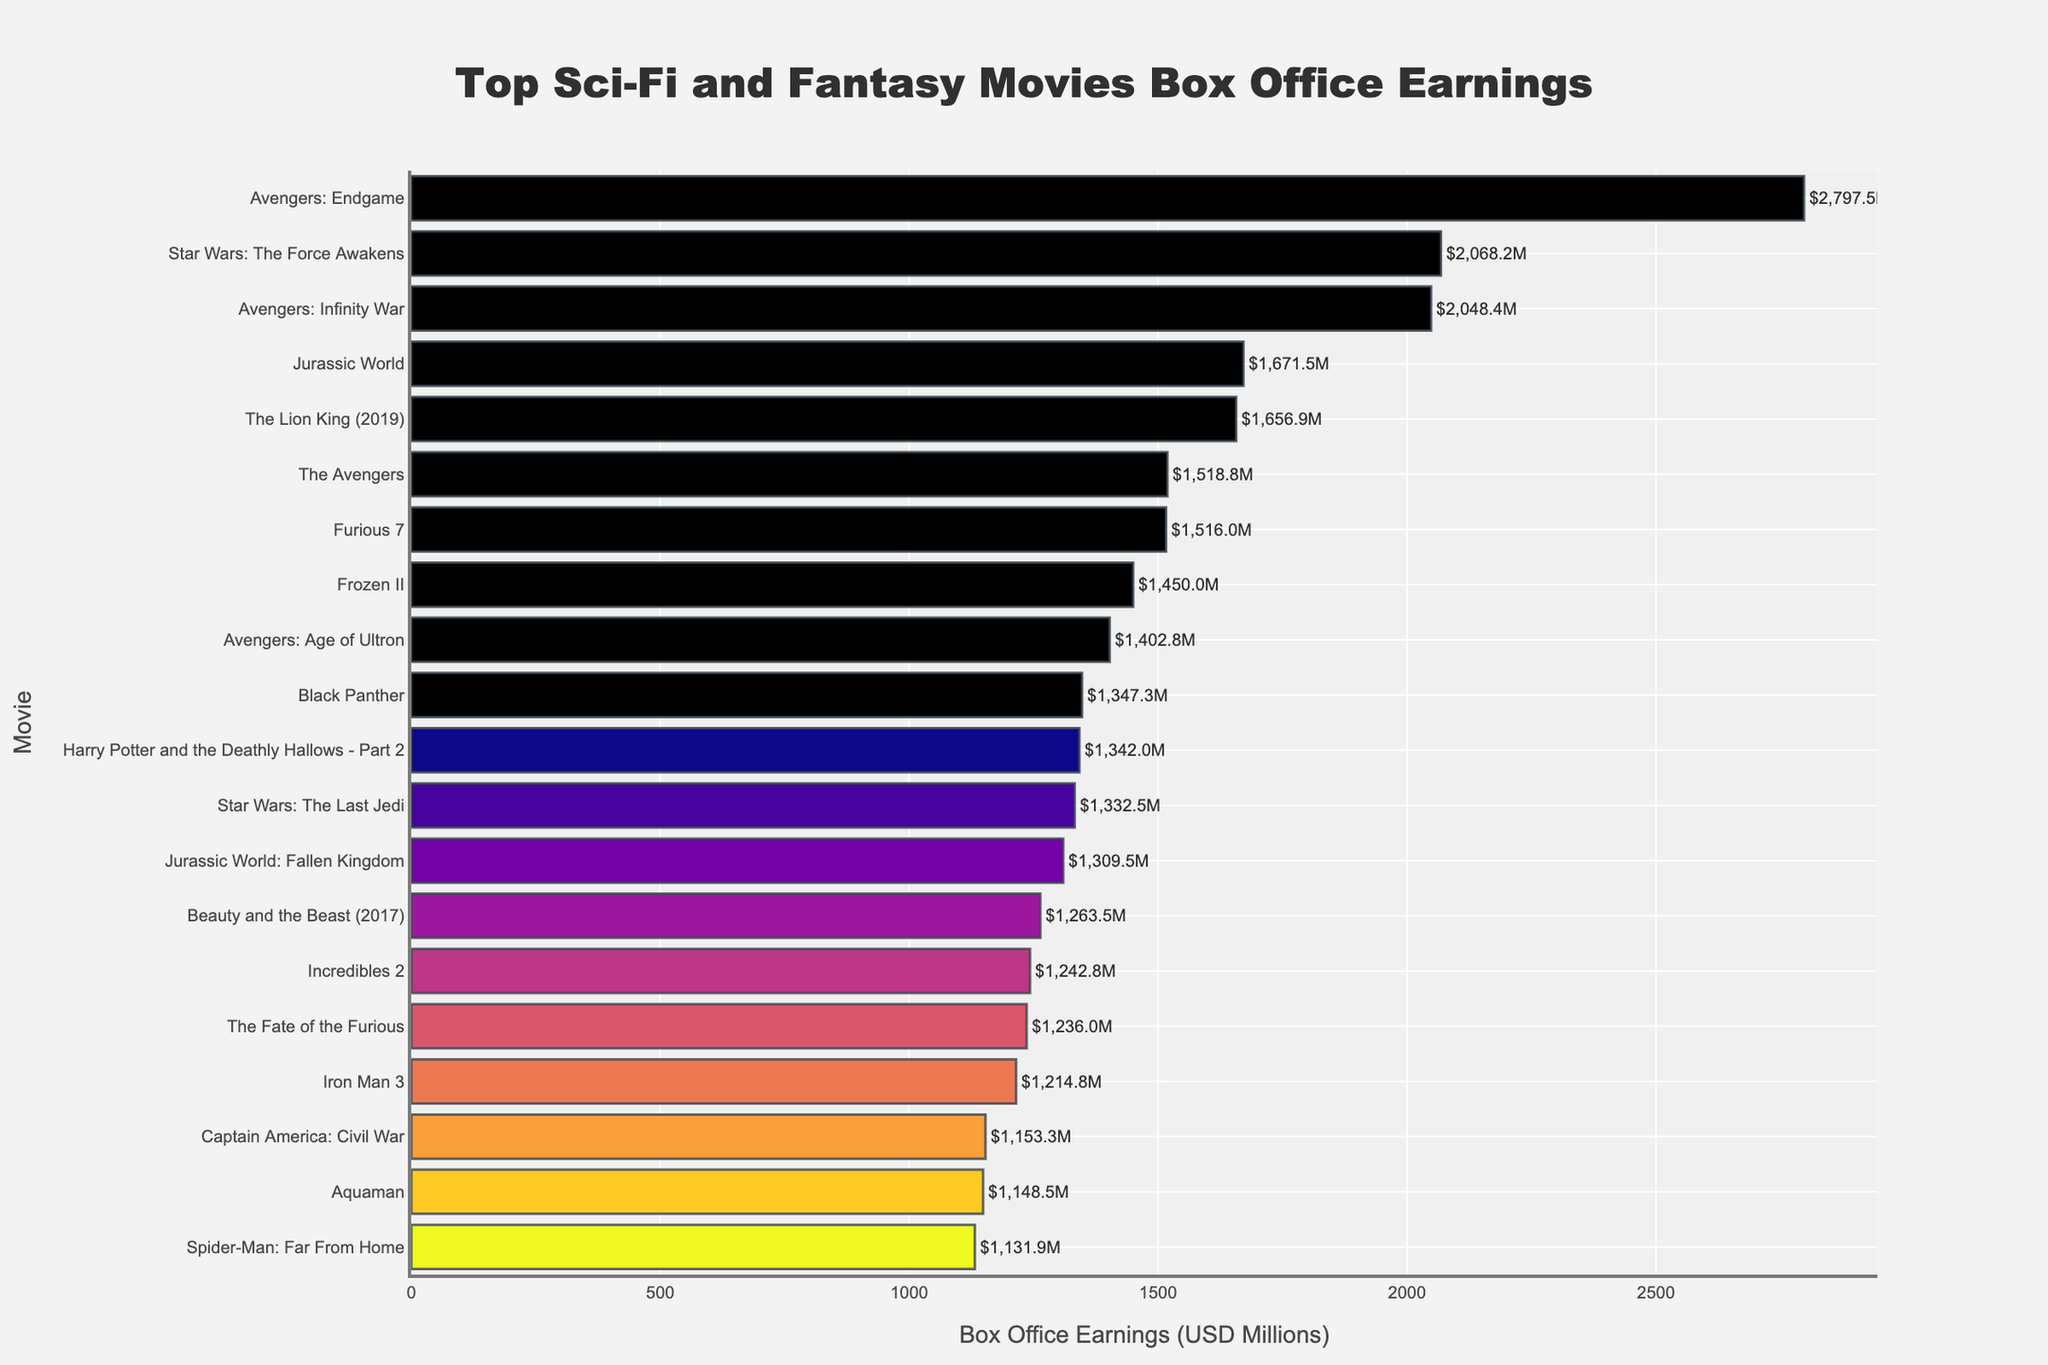Which movie has the highest box office earnings? The bar for "Avengers: Endgame" is the longest, indicating it has the highest earnings among the movies listed.
Answer: Avengers: Endgame Which two movies have box office earnings closest to each other? "Captain America: Civil War" and "Aquaman" have very similar bar lengths, indicating their earnings are close. Hence, their values need to be checked: $1153.3M for Captain America: Civil War and $1148.5M for Aquaman.
Answer: Captain America: Civil War and Aquaman What is the total box office earnings of the top 3 movies? The top three movies are "Avengers: Endgame" ($2797.5M), "Star Wars: The Force Awakens" ($2068.2M), and "Avengers: Infinity War" ($2048.4M). Summing them up: 2797.5 + 2068.2 + 2048.4 = 6914.1M
Answer: 6914.1M How many movies have box office earnings above $1500 million? By observing the bars and their associated values, the movies "Avengers: Endgame," "Star Wars: The Force Awakens," "Avengers: Infinity War," "Jurassic World," "The Lion King (2019)," "The Avengers," and "Furious 7" all have earnings above $1500M.
Answer: 7 Which movie's earnings are approximately halfway between the highest and lowest earnings in the list? The highest earnings are $2797.5M (Avengers: Endgame) and the lowest are $1131.9M (Spider-Man: Far From Home). The midpoint is (2797.5 + 1131.9) / 2 = 1964.7M. Star Wars: The Force Awakens has earnings closest to this midpoint with $2068.2M.
Answer: Star Wars: The Force Awakens Which movie is ranked fifth in box office earnings? The fifth highest earnings are shown by "The Lion King (2019)" with $1656.9M. It is the fifth longest bar on the graph.
Answer: The Lion King (2019) What is the difference in box office earnings between "Frozen II" and "Incredibles 2"? "Frozen II" has earnings of $1450.0M, and "Incredibles 2" has $1242.8M. The difference is 1450.0 - 1242.8 = $207.2M.
Answer: $207.2M 